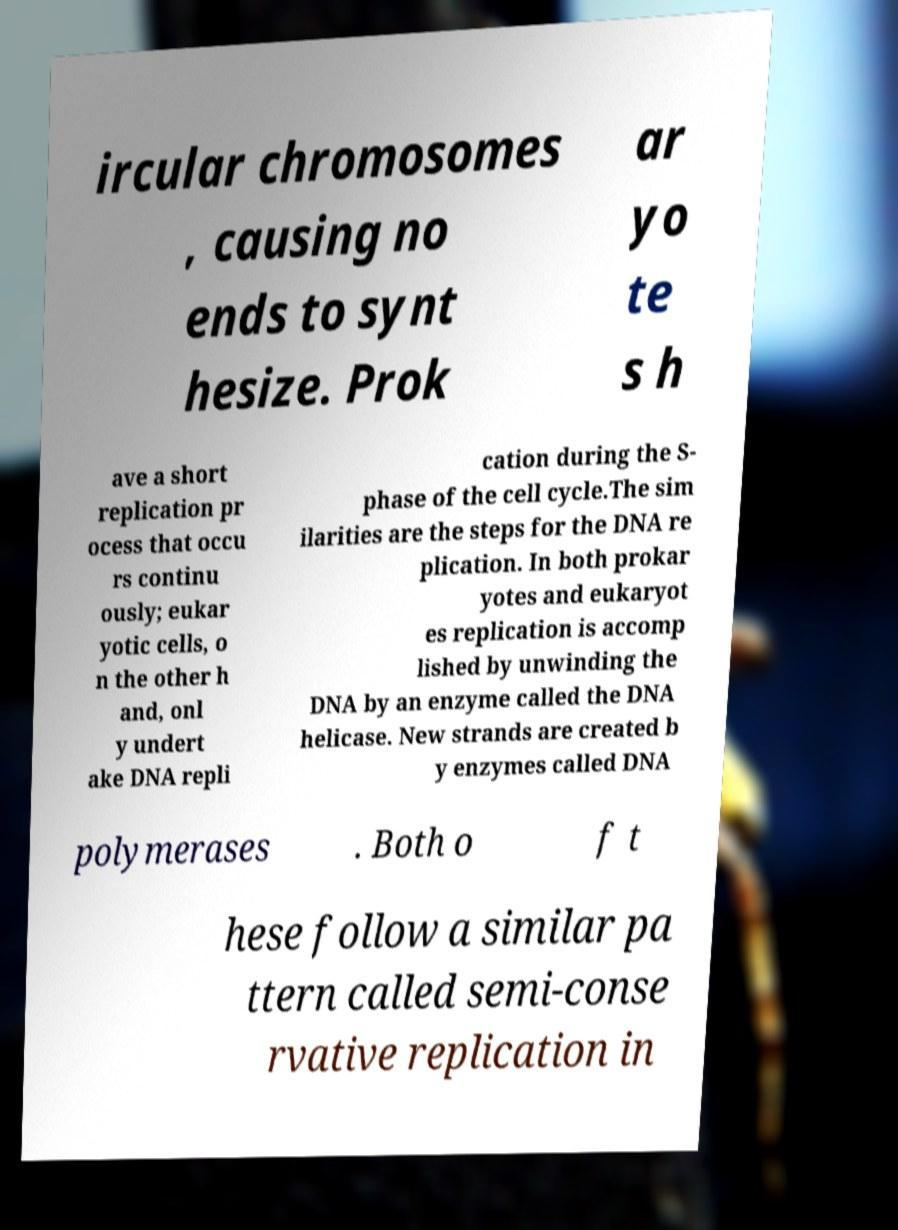For documentation purposes, I need the text within this image transcribed. Could you provide that? ircular chromosomes , causing no ends to synt hesize. Prok ar yo te s h ave a short replication pr ocess that occu rs continu ously; eukar yotic cells, o n the other h and, onl y undert ake DNA repli cation during the S- phase of the cell cycle.The sim ilarities are the steps for the DNA re plication. In both prokar yotes and eukaryot es replication is accomp lished by unwinding the DNA by an enzyme called the DNA helicase. New strands are created b y enzymes called DNA polymerases . Both o f t hese follow a similar pa ttern called semi-conse rvative replication in 